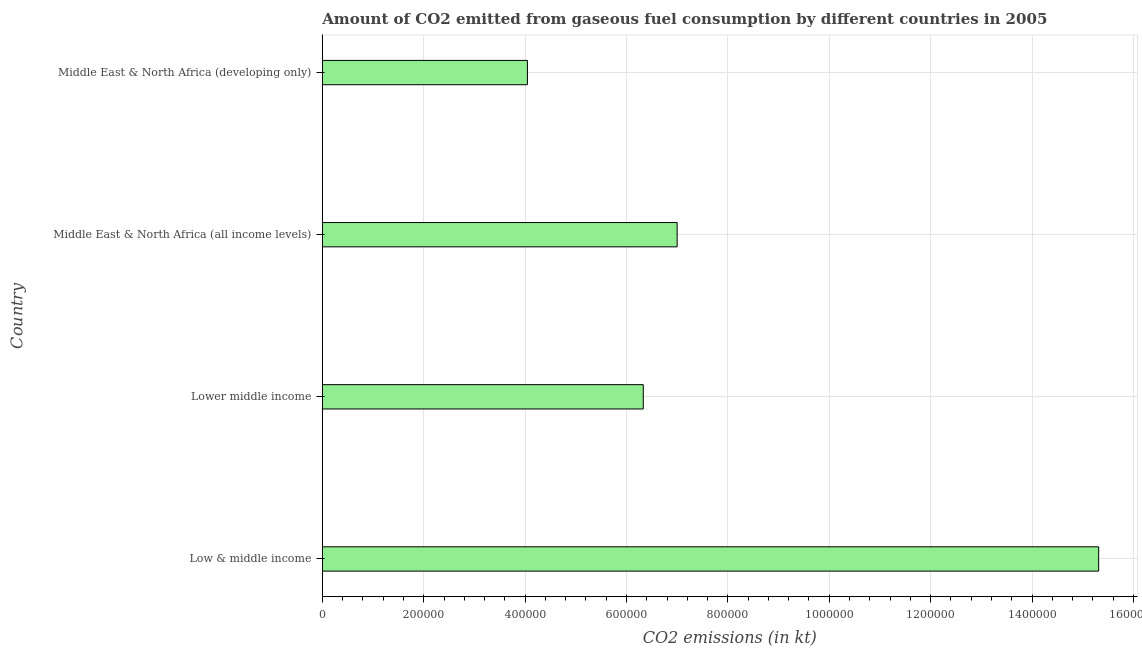What is the title of the graph?
Make the answer very short. Amount of CO2 emitted from gaseous fuel consumption by different countries in 2005. What is the label or title of the X-axis?
Offer a very short reply. CO2 emissions (in kt). What is the co2 emissions from gaseous fuel consumption in Low & middle income?
Keep it short and to the point. 1.53e+06. Across all countries, what is the maximum co2 emissions from gaseous fuel consumption?
Provide a short and direct response. 1.53e+06. Across all countries, what is the minimum co2 emissions from gaseous fuel consumption?
Your response must be concise. 4.05e+05. In which country was the co2 emissions from gaseous fuel consumption maximum?
Your answer should be compact. Low & middle income. In which country was the co2 emissions from gaseous fuel consumption minimum?
Make the answer very short. Middle East & North Africa (developing only). What is the sum of the co2 emissions from gaseous fuel consumption?
Give a very brief answer. 3.27e+06. What is the difference between the co2 emissions from gaseous fuel consumption in Low & middle income and Middle East & North Africa (developing only)?
Your answer should be compact. 1.13e+06. What is the average co2 emissions from gaseous fuel consumption per country?
Keep it short and to the point. 8.17e+05. What is the median co2 emissions from gaseous fuel consumption?
Give a very brief answer. 6.67e+05. What is the ratio of the co2 emissions from gaseous fuel consumption in Low & middle income to that in Middle East & North Africa (all income levels)?
Your answer should be compact. 2.19. Is the co2 emissions from gaseous fuel consumption in Low & middle income less than that in Middle East & North Africa (developing only)?
Give a very brief answer. No. Is the difference between the co2 emissions from gaseous fuel consumption in Low & middle income and Middle East & North Africa (developing only) greater than the difference between any two countries?
Provide a short and direct response. Yes. What is the difference between the highest and the second highest co2 emissions from gaseous fuel consumption?
Offer a very short reply. 8.32e+05. What is the difference between the highest and the lowest co2 emissions from gaseous fuel consumption?
Make the answer very short. 1.13e+06. In how many countries, is the co2 emissions from gaseous fuel consumption greater than the average co2 emissions from gaseous fuel consumption taken over all countries?
Provide a short and direct response. 1. How many bars are there?
Give a very brief answer. 4. How many countries are there in the graph?
Provide a short and direct response. 4. What is the difference between two consecutive major ticks on the X-axis?
Offer a very short reply. 2.00e+05. Are the values on the major ticks of X-axis written in scientific E-notation?
Give a very brief answer. No. What is the CO2 emissions (in kt) of Low & middle income?
Offer a very short reply. 1.53e+06. What is the CO2 emissions (in kt) of Lower middle income?
Your answer should be very brief. 6.33e+05. What is the CO2 emissions (in kt) in Middle East & North Africa (all income levels)?
Offer a terse response. 7.00e+05. What is the CO2 emissions (in kt) in Middle East & North Africa (developing only)?
Give a very brief answer. 4.05e+05. What is the difference between the CO2 emissions (in kt) in Low & middle income and Lower middle income?
Keep it short and to the point. 8.98e+05. What is the difference between the CO2 emissions (in kt) in Low & middle income and Middle East & North Africa (all income levels)?
Your answer should be compact. 8.32e+05. What is the difference between the CO2 emissions (in kt) in Low & middle income and Middle East & North Africa (developing only)?
Your answer should be compact. 1.13e+06. What is the difference between the CO2 emissions (in kt) in Lower middle income and Middle East & North Africa (all income levels)?
Provide a short and direct response. -6.68e+04. What is the difference between the CO2 emissions (in kt) in Lower middle income and Middle East & North Africa (developing only)?
Give a very brief answer. 2.29e+05. What is the difference between the CO2 emissions (in kt) in Middle East & North Africa (all income levels) and Middle East & North Africa (developing only)?
Your answer should be very brief. 2.95e+05. What is the ratio of the CO2 emissions (in kt) in Low & middle income to that in Lower middle income?
Your answer should be compact. 2.42. What is the ratio of the CO2 emissions (in kt) in Low & middle income to that in Middle East & North Africa (all income levels)?
Offer a very short reply. 2.19. What is the ratio of the CO2 emissions (in kt) in Low & middle income to that in Middle East & North Africa (developing only)?
Provide a short and direct response. 3.79. What is the ratio of the CO2 emissions (in kt) in Lower middle income to that in Middle East & North Africa (all income levels)?
Your answer should be compact. 0.91. What is the ratio of the CO2 emissions (in kt) in Lower middle income to that in Middle East & North Africa (developing only)?
Offer a terse response. 1.56. What is the ratio of the CO2 emissions (in kt) in Middle East & North Africa (all income levels) to that in Middle East & North Africa (developing only)?
Provide a succinct answer. 1.73. 